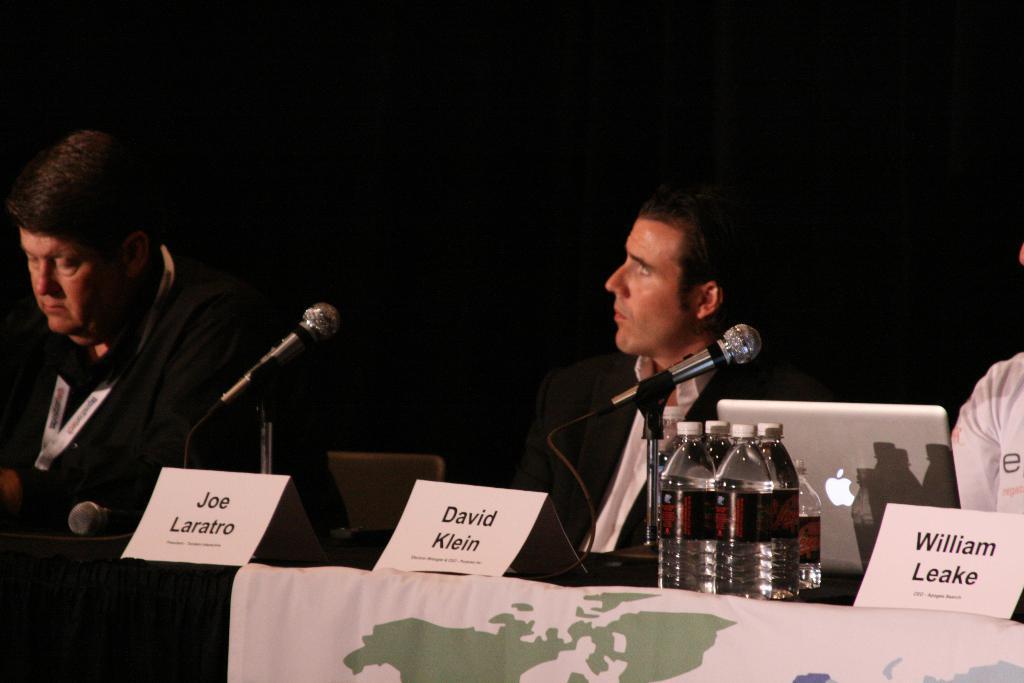How would you summarize this image in a sentence or two? In this image I see 3 persons and all of them are sitting in front of a table. On the table I see 3 name boards, few bottles, a laptop and 2 mics. 